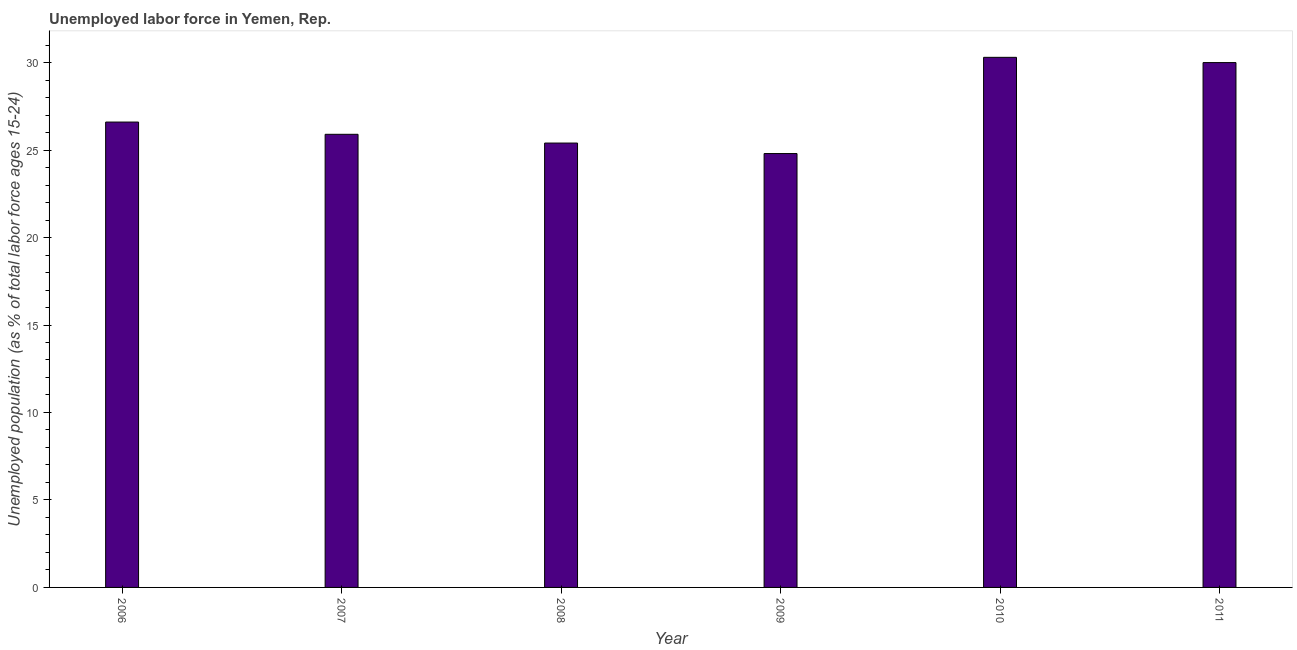Does the graph contain grids?
Offer a very short reply. No. What is the title of the graph?
Provide a succinct answer. Unemployed labor force in Yemen, Rep. What is the label or title of the X-axis?
Offer a terse response. Year. What is the label or title of the Y-axis?
Offer a terse response. Unemployed population (as % of total labor force ages 15-24). What is the total unemployed youth population in 2008?
Keep it short and to the point. 25.4. Across all years, what is the maximum total unemployed youth population?
Ensure brevity in your answer.  30.3. Across all years, what is the minimum total unemployed youth population?
Offer a terse response. 24.8. What is the sum of the total unemployed youth population?
Provide a short and direct response. 163. What is the difference between the total unemployed youth population in 2010 and 2011?
Make the answer very short. 0.3. What is the average total unemployed youth population per year?
Make the answer very short. 27.17. What is the median total unemployed youth population?
Offer a terse response. 26.25. What is the ratio of the total unemployed youth population in 2008 to that in 2009?
Make the answer very short. 1.02. Is the total unemployed youth population in 2008 less than that in 2010?
Provide a succinct answer. Yes. Is the difference between the total unemployed youth population in 2007 and 2009 greater than the difference between any two years?
Your answer should be compact. No. Is the sum of the total unemployed youth population in 2006 and 2011 greater than the maximum total unemployed youth population across all years?
Keep it short and to the point. Yes. What is the difference between the highest and the lowest total unemployed youth population?
Offer a very short reply. 5.5. How many bars are there?
Provide a short and direct response. 6. Are all the bars in the graph horizontal?
Ensure brevity in your answer.  No. How many years are there in the graph?
Offer a terse response. 6. What is the difference between two consecutive major ticks on the Y-axis?
Make the answer very short. 5. Are the values on the major ticks of Y-axis written in scientific E-notation?
Your answer should be compact. No. What is the Unemployed population (as % of total labor force ages 15-24) in 2006?
Offer a very short reply. 26.6. What is the Unemployed population (as % of total labor force ages 15-24) in 2007?
Provide a short and direct response. 25.9. What is the Unemployed population (as % of total labor force ages 15-24) of 2008?
Your response must be concise. 25.4. What is the Unemployed population (as % of total labor force ages 15-24) in 2009?
Make the answer very short. 24.8. What is the Unemployed population (as % of total labor force ages 15-24) of 2010?
Give a very brief answer. 30.3. What is the Unemployed population (as % of total labor force ages 15-24) of 2011?
Ensure brevity in your answer.  30. What is the difference between the Unemployed population (as % of total labor force ages 15-24) in 2006 and 2008?
Make the answer very short. 1.2. What is the difference between the Unemployed population (as % of total labor force ages 15-24) in 2007 and 2010?
Provide a succinct answer. -4.4. What is the difference between the Unemployed population (as % of total labor force ages 15-24) in 2008 and 2009?
Your response must be concise. 0.6. What is the difference between the Unemployed population (as % of total labor force ages 15-24) in 2008 and 2011?
Offer a very short reply. -4.6. What is the difference between the Unemployed population (as % of total labor force ages 15-24) in 2010 and 2011?
Offer a very short reply. 0.3. What is the ratio of the Unemployed population (as % of total labor force ages 15-24) in 2006 to that in 2008?
Provide a short and direct response. 1.05. What is the ratio of the Unemployed population (as % of total labor force ages 15-24) in 2006 to that in 2009?
Make the answer very short. 1.07. What is the ratio of the Unemployed population (as % of total labor force ages 15-24) in 2006 to that in 2010?
Ensure brevity in your answer.  0.88. What is the ratio of the Unemployed population (as % of total labor force ages 15-24) in 2006 to that in 2011?
Make the answer very short. 0.89. What is the ratio of the Unemployed population (as % of total labor force ages 15-24) in 2007 to that in 2009?
Your answer should be very brief. 1.04. What is the ratio of the Unemployed population (as % of total labor force ages 15-24) in 2007 to that in 2010?
Offer a terse response. 0.85. What is the ratio of the Unemployed population (as % of total labor force ages 15-24) in 2007 to that in 2011?
Your answer should be compact. 0.86. What is the ratio of the Unemployed population (as % of total labor force ages 15-24) in 2008 to that in 2009?
Make the answer very short. 1.02. What is the ratio of the Unemployed population (as % of total labor force ages 15-24) in 2008 to that in 2010?
Ensure brevity in your answer.  0.84. What is the ratio of the Unemployed population (as % of total labor force ages 15-24) in 2008 to that in 2011?
Your answer should be very brief. 0.85. What is the ratio of the Unemployed population (as % of total labor force ages 15-24) in 2009 to that in 2010?
Ensure brevity in your answer.  0.82. What is the ratio of the Unemployed population (as % of total labor force ages 15-24) in 2009 to that in 2011?
Give a very brief answer. 0.83. 